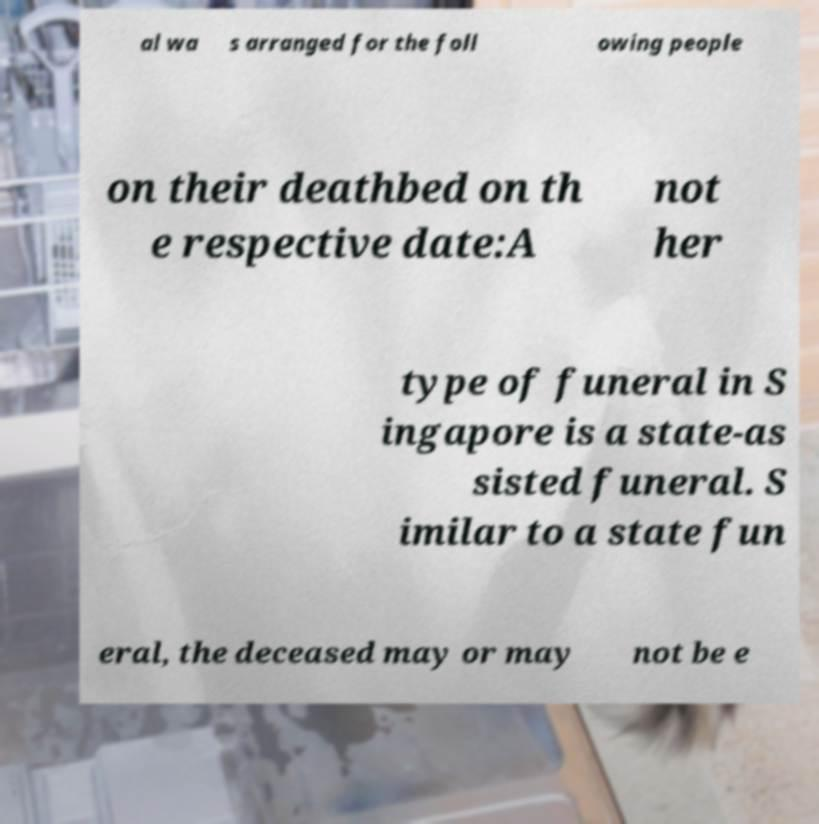For documentation purposes, I need the text within this image transcribed. Could you provide that? al wa s arranged for the foll owing people on their deathbed on th e respective date:A not her type of funeral in S ingapore is a state-as sisted funeral. S imilar to a state fun eral, the deceased may or may not be e 